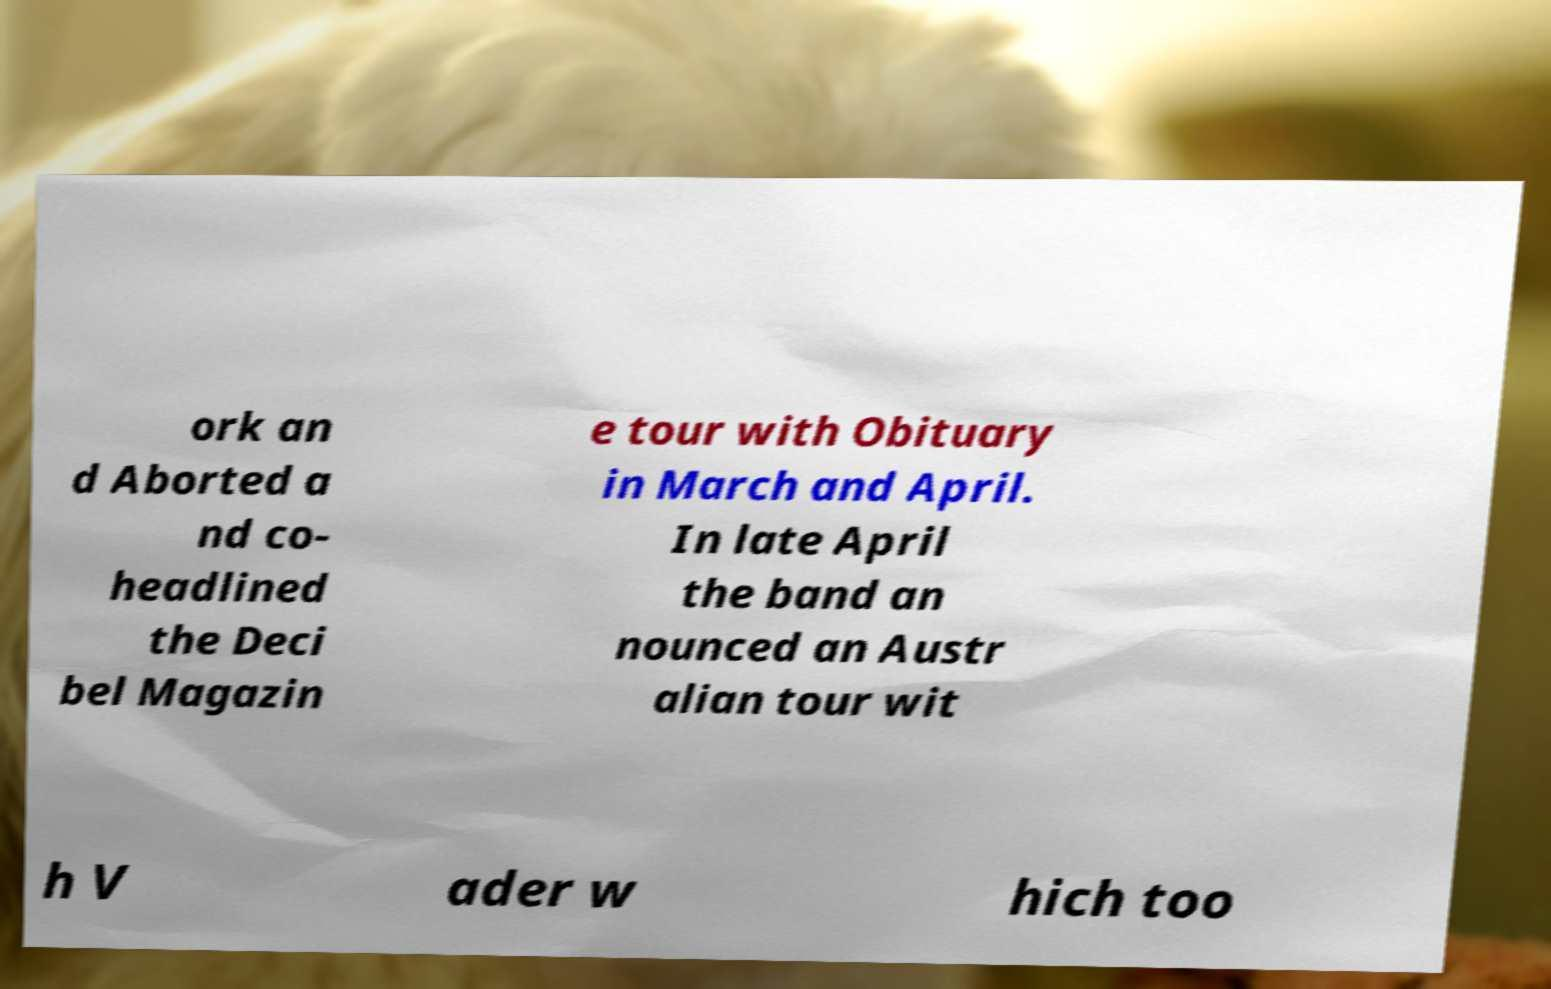Can you read and provide the text displayed in the image?This photo seems to have some interesting text. Can you extract and type it out for me? ork an d Aborted a nd co- headlined the Deci bel Magazin e tour with Obituary in March and April. In late April the band an nounced an Austr alian tour wit h V ader w hich too 